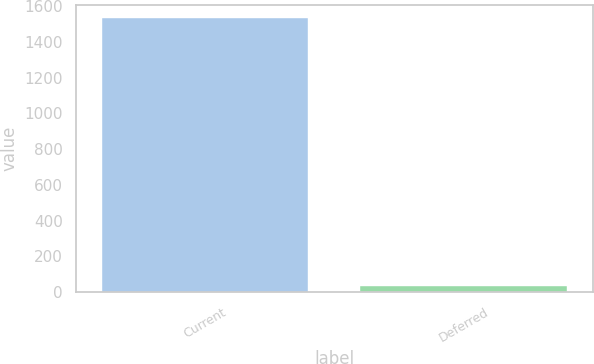Convert chart. <chart><loc_0><loc_0><loc_500><loc_500><bar_chart><fcel>Current<fcel>Deferred<nl><fcel>1533<fcel>35<nl></chart> 